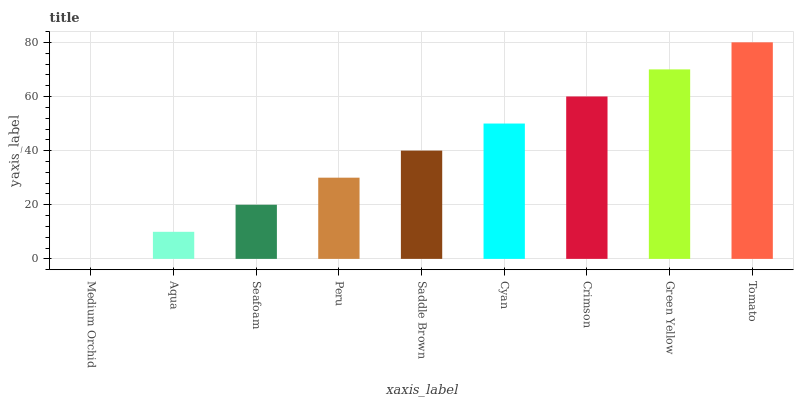Is Medium Orchid the minimum?
Answer yes or no. Yes. Is Tomato the maximum?
Answer yes or no. Yes. Is Aqua the minimum?
Answer yes or no. No. Is Aqua the maximum?
Answer yes or no. No. Is Aqua greater than Medium Orchid?
Answer yes or no. Yes. Is Medium Orchid less than Aqua?
Answer yes or no. Yes. Is Medium Orchid greater than Aqua?
Answer yes or no. No. Is Aqua less than Medium Orchid?
Answer yes or no. No. Is Saddle Brown the high median?
Answer yes or no. Yes. Is Saddle Brown the low median?
Answer yes or no. Yes. Is Tomato the high median?
Answer yes or no. No. Is Cyan the low median?
Answer yes or no. No. 